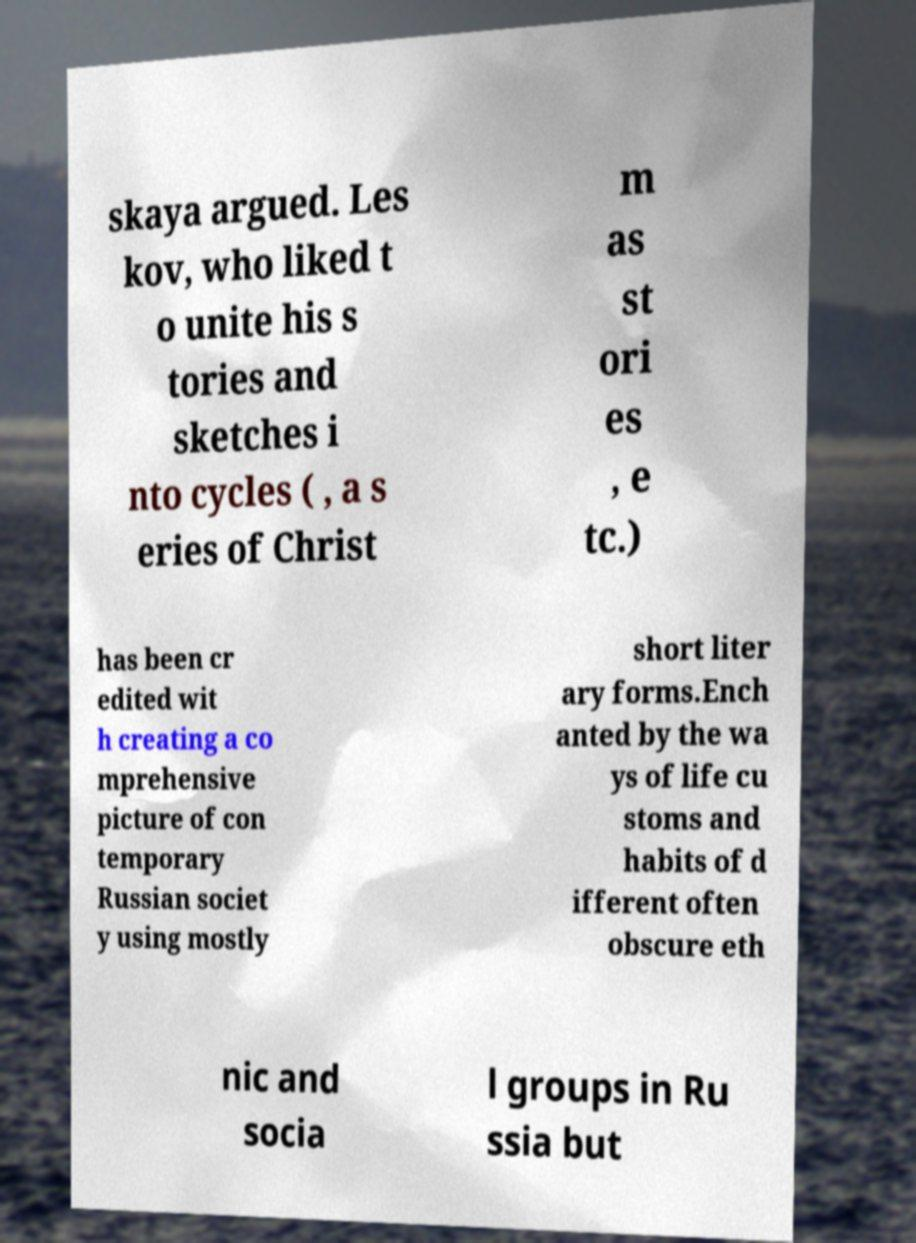Can you read and provide the text displayed in the image?This photo seems to have some interesting text. Can you extract and type it out for me? skaya argued. Les kov, who liked t o unite his s tories and sketches i nto cycles ( , a s eries of Christ m as st ori es , e tc.) has been cr edited wit h creating a co mprehensive picture of con temporary Russian societ y using mostly short liter ary forms.Ench anted by the wa ys of life cu stoms and habits of d ifferent often obscure eth nic and socia l groups in Ru ssia but 